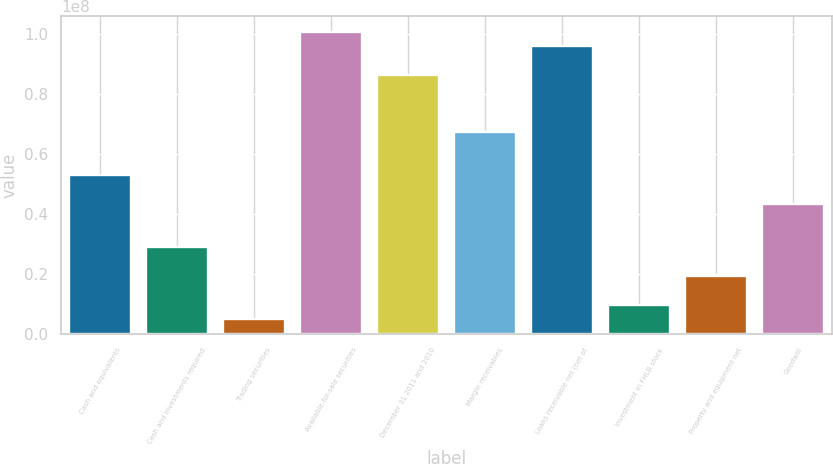Convert chart. <chart><loc_0><loc_0><loc_500><loc_500><bar_chart><fcel>Cash and equivalents<fcel>Cash and investments required<fcel>Trading securities<fcel>Available-for-sale securities<fcel>December 31 2011 and 2010<fcel>Margin receivables<fcel>Loans receivable net (net of<fcel>Investment in FHLB stock<fcel>Property and equipment net<fcel>Goodwill<nl><fcel>5.27342e+07<fcel>2.87654e+07<fcel>4.79661e+06<fcel>1.00672e+08<fcel>8.62905e+07<fcel>6.71155e+07<fcel>9.5878e+07<fcel>9.59037e+06<fcel>1.91779e+07<fcel>4.31467e+07<nl></chart> 